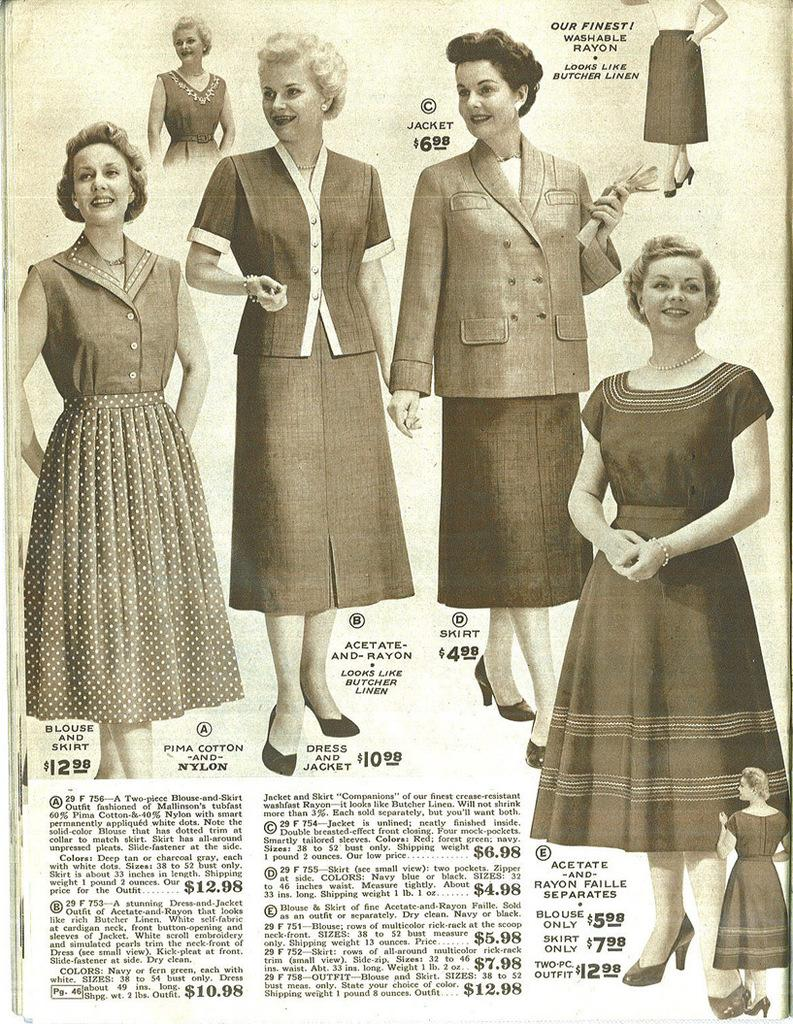What is the main subject of the paper in the image? The paper contains a picture of women wearing dresses. What can be found at the bottom of the paper? There is a quotation at the bottom of the paper. What type of pies are being served by the goat in the image? There is no goat or pies present in the image; it features a paper with a picture of women wearing dresses and a quotation. What song is being sung by the women in the image? There is no indication of a song being sung in the image; it only contains a picture of women wearing dresses and a quotation. 